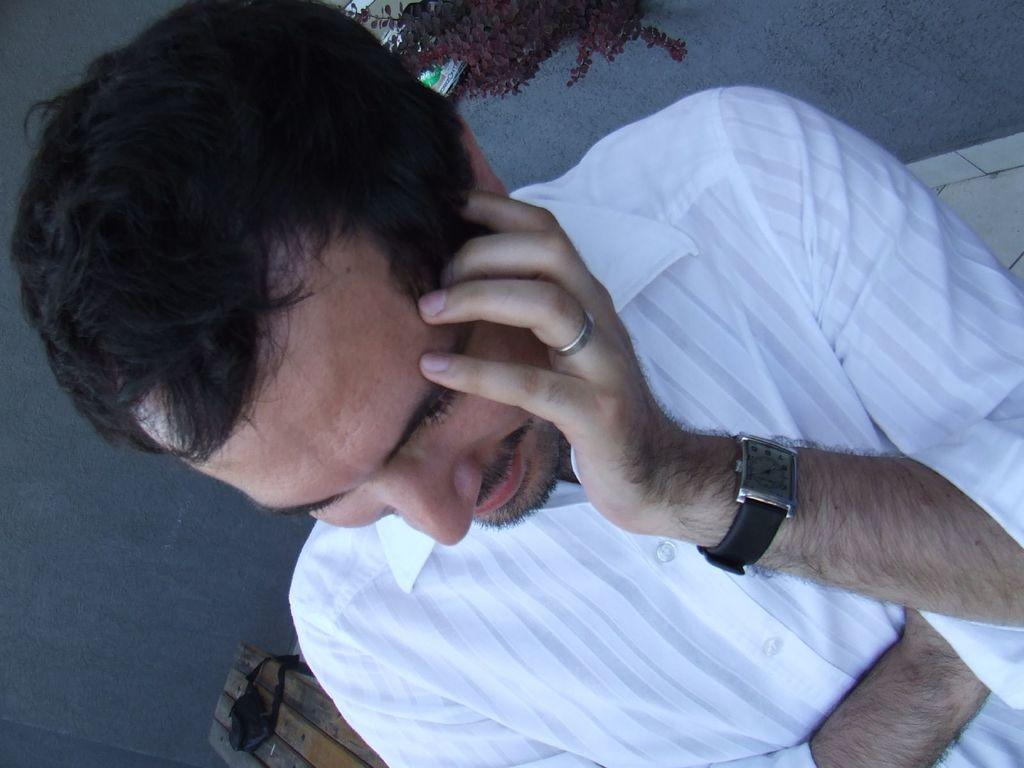Who is present in the image? There is a man in the image. What is the man sitting on in the image? There is a bench in the image. What can be seen in the background of the image? There is a plant and a wall in the background of the image. What object is on the bench in the image? There is a small bag on the bench. What is the man's tendency to sit on chairs in the image? The image does not show the man sitting on a chair, but rather on a bench. What need does the man have for a ladder in the image? There is no ladder present in the image, and no indication of a need for one. 